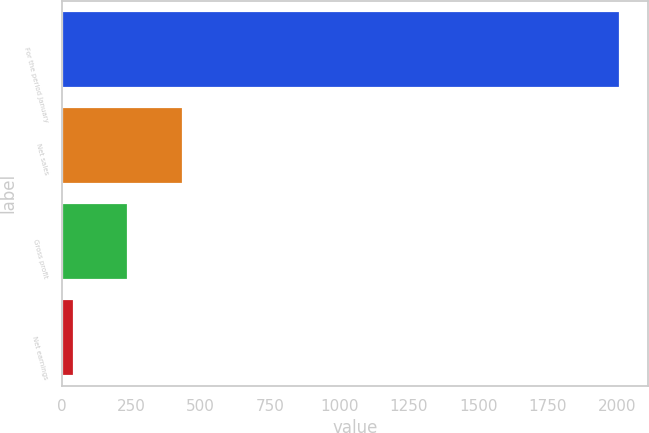<chart> <loc_0><loc_0><loc_500><loc_500><bar_chart><fcel>For the period January<fcel>Net sales<fcel>Gross profit<fcel>Net earnings<nl><fcel>2012<fcel>436.16<fcel>239.18<fcel>42.2<nl></chart> 